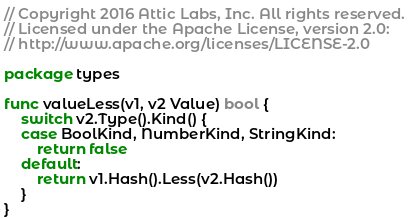<code> <loc_0><loc_0><loc_500><loc_500><_Go_>// Copyright 2016 Attic Labs, Inc. All rights reserved.
// Licensed under the Apache License, version 2.0:
// http://www.apache.org/licenses/LICENSE-2.0

package types

func valueLess(v1, v2 Value) bool {
	switch v2.Type().Kind() {
	case BoolKind, NumberKind, StringKind:
		return false
	default:
		return v1.Hash().Less(v2.Hash())
	}
}
</code> 